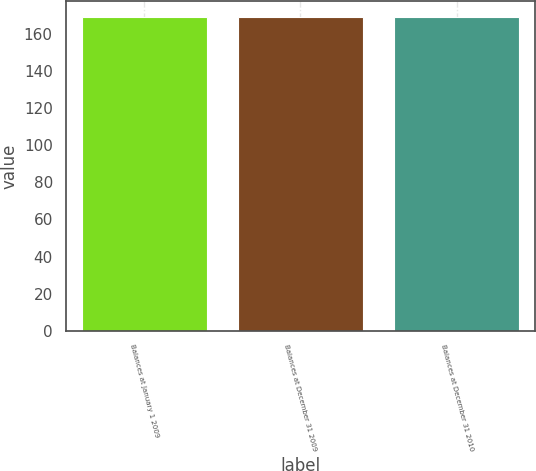<chart> <loc_0><loc_0><loc_500><loc_500><bar_chart><fcel>Balances at January 1 2009<fcel>Balances at December 31 2009<fcel>Balances at December 31 2010<nl><fcel>169<fcel>169.1<fcel>169.2<nl></chart> 